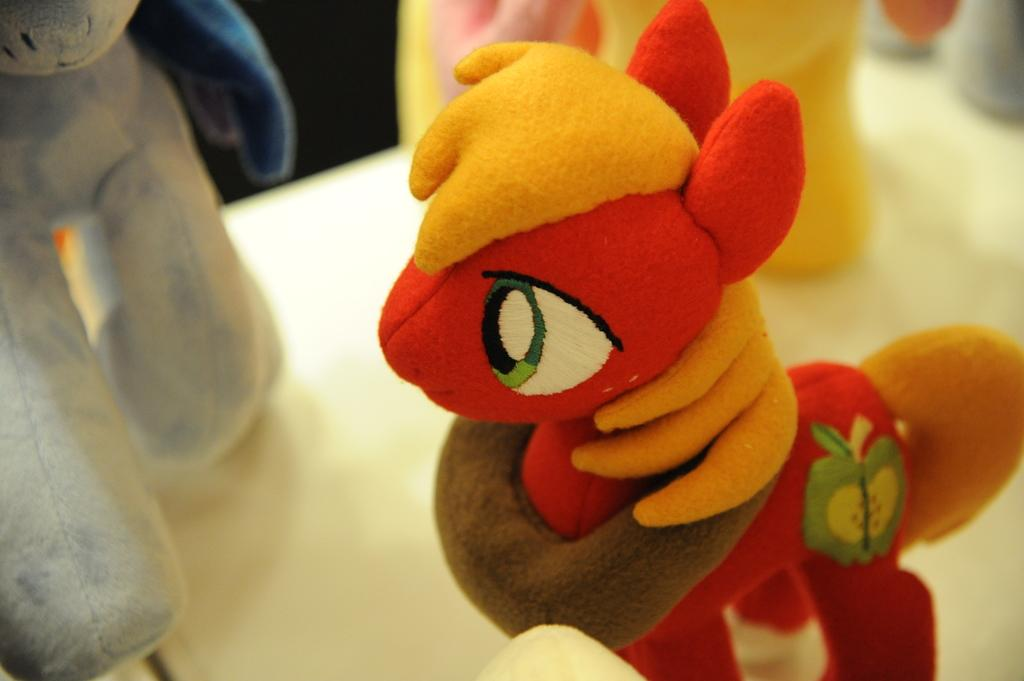What is the main subject of the image? The main subject of the image is a zoomed-in view of toys. What can be observed about the placement of the toys in the image? The toys are placed on a white surface. How many fish are swimming in the water near the toys in the image? There are no fish or water present in the image; it is a zoomed-in view of toys placed on a white surface. 